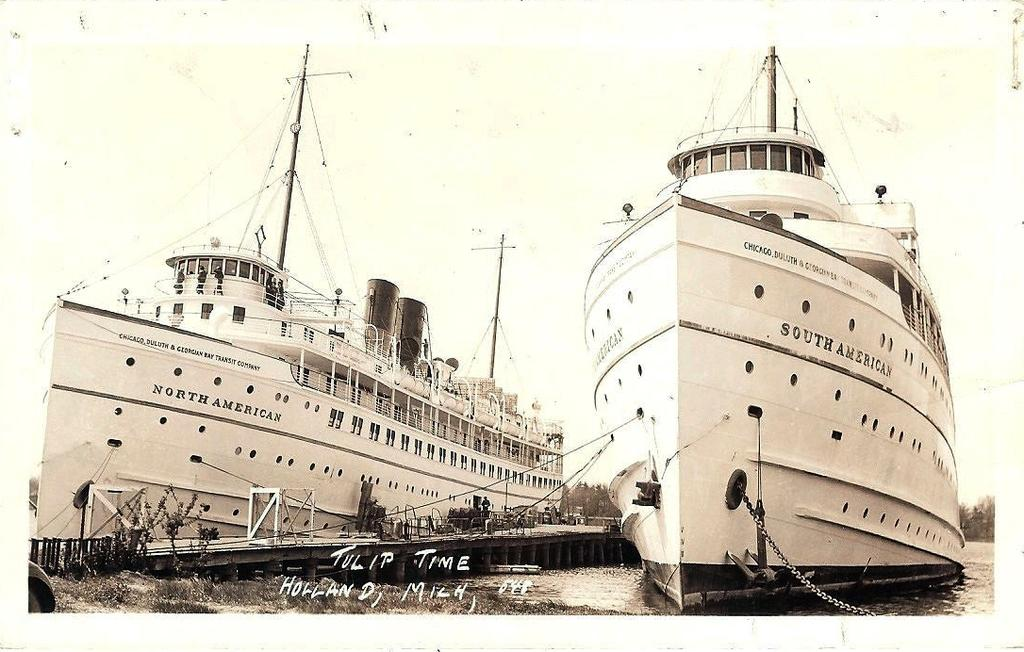Provide a one-sentence caption for the provided image. The North American and South  American ship sitting at a dock. 